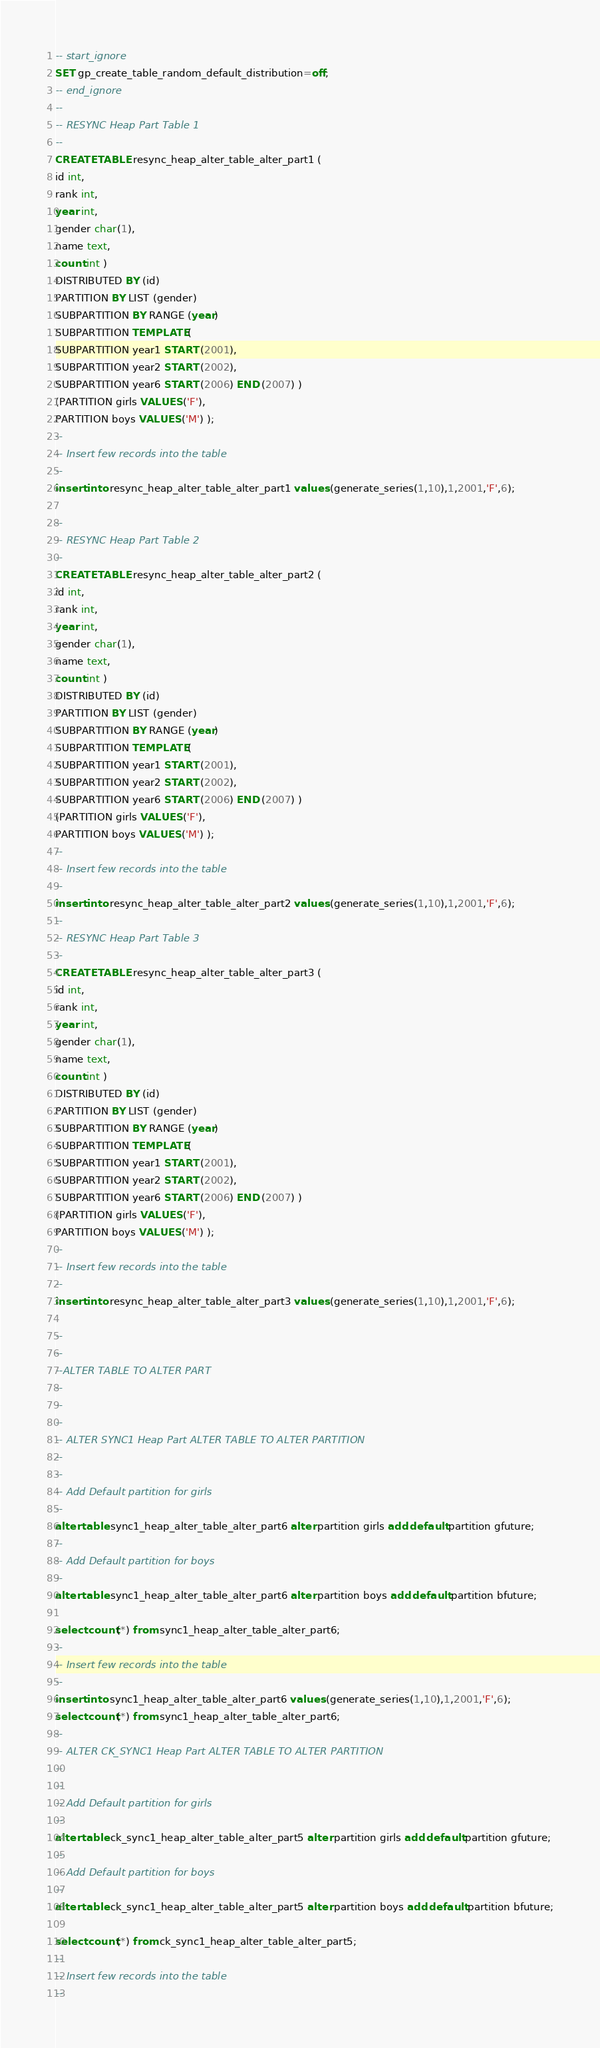<code> <loc_0><loc_0><loc_500><loc_500><_SQL_>-- start_ignore
SET gp_create_table_random_default_distribution=off;
-- end_ignore
--
-- RESYNC Heap Part Table 1
--
CREATE TABLE resync_heap_alter_table_alter_part1 (
id int,
rank int,
year int,
gender char(1),
name text,
count int ) 
DISTRIBUTED BY (id)
PARTITION BY LIST (gender)
SUBPARTITION BY RANGE (year)
SUBPARTITION TEMPLATE (
SUBPARTITION year1 START (2001),
SUBPARTITION year2 START (2002),
SUBPARTITION year6 START (2006) END (2007) )
(PARTITION girls VALUES ('F'),
PARTITION boys VALUES ('M') );
--
-- Insert few records into the table
--
insert into resync_heap_alter_table_alter_part1 values (generate_series(1,10),1,2001,'F',6);

--
-- RESYNC Heap Part Table 2
--
CREATE TABLE resync_heap_alter_table_alter_part2 (
id int,
rank int,
year int,
gender char(1),
name text,
count int ) 
DISTRIBUTED BY (id)
PARTITION BY LIST (gender)
SUBPARTITION BY RANGE (year)
SUBPARTITION TEMPLATE (
SUBPARTITION year1 START (2001),
SUBPARTITION year2 START (2002),
SUBPARTITION year6 START (2006) END (2007) )
(PARTITION girls VALUES ('F'),
PARTITION boys VALUES ('M') );
--
-- Insert few records into the table
--
insert into resync_heap_alter_table_alter_part2 values (generate_series(1,10),1,2001,'F',6);
--
-- RESYNC Heap Part Table 3
--
CREATE TABLE resync_heap_alter_table_alter_part3 (
id int,
rank int,
year int,
gender char(1),
name text,
count int ) 
DISTRIBUTED BY (id)
PARTITION BY LIST (gender)
SUBPARTITION BY RANGE (year)
SUBPARTITION TEMPLATE (
SUBPARTITION year1 START (2001),
SUBPARTITION year2 START (2002),
SUBPARTITION year6 START (2006) END (2007) )
(PARTITION girls VALUES ('F'),
PARTITION boys VALUES ('M') );
--
-- Insert few records into the table
--
insert into resync_heap_alter_table_alter_part3 values (generate_series(1,10),1,2001,'F',6);

--
--
--ALTER TABLE TO ALTER PART
--
--
--
-- ALTER SYNC1 Heap Part ALTER TABLE TO ALTER PARTITION
--
--
-- Add Default partition for girls
--
alter table sync1_heap_alter_table_alter_part6 alter partition girls add default partition gfuture;
--
-- Add Default partition for boys
--
alter table sync1_heap_alter_table_alter_part6 alter partition boys add default partition bfuture;

select count(*) from sync1_heap_alter_table_alter_part6;
--
-- Insert few records into the table
--
insert into sync1_heap_alter_table_alter_part6 values (generate_series(1,10),1,2001,'F',6);
select count(*) from sync1_heap_alter_table_alter_part6;
--
-- ALTER CK_SYNC1 Heap Part ALTER TABLE TO ALTER PARTITION
--
--
-- Add Default partition for girls
--
alter table ck_sync1_heap_alter_table_alter_part5 alter partition girls add default partition gfuture;
--
-- Add Default partition for boys
--
alter table ck_sync1_heap_alter_table_alter_part5 alter partition boys add default partition bfuture;

select count(*) from ck_sync1_heap_alter_table_alter_part5;
--
-- Insert few records into the table
--</code> 